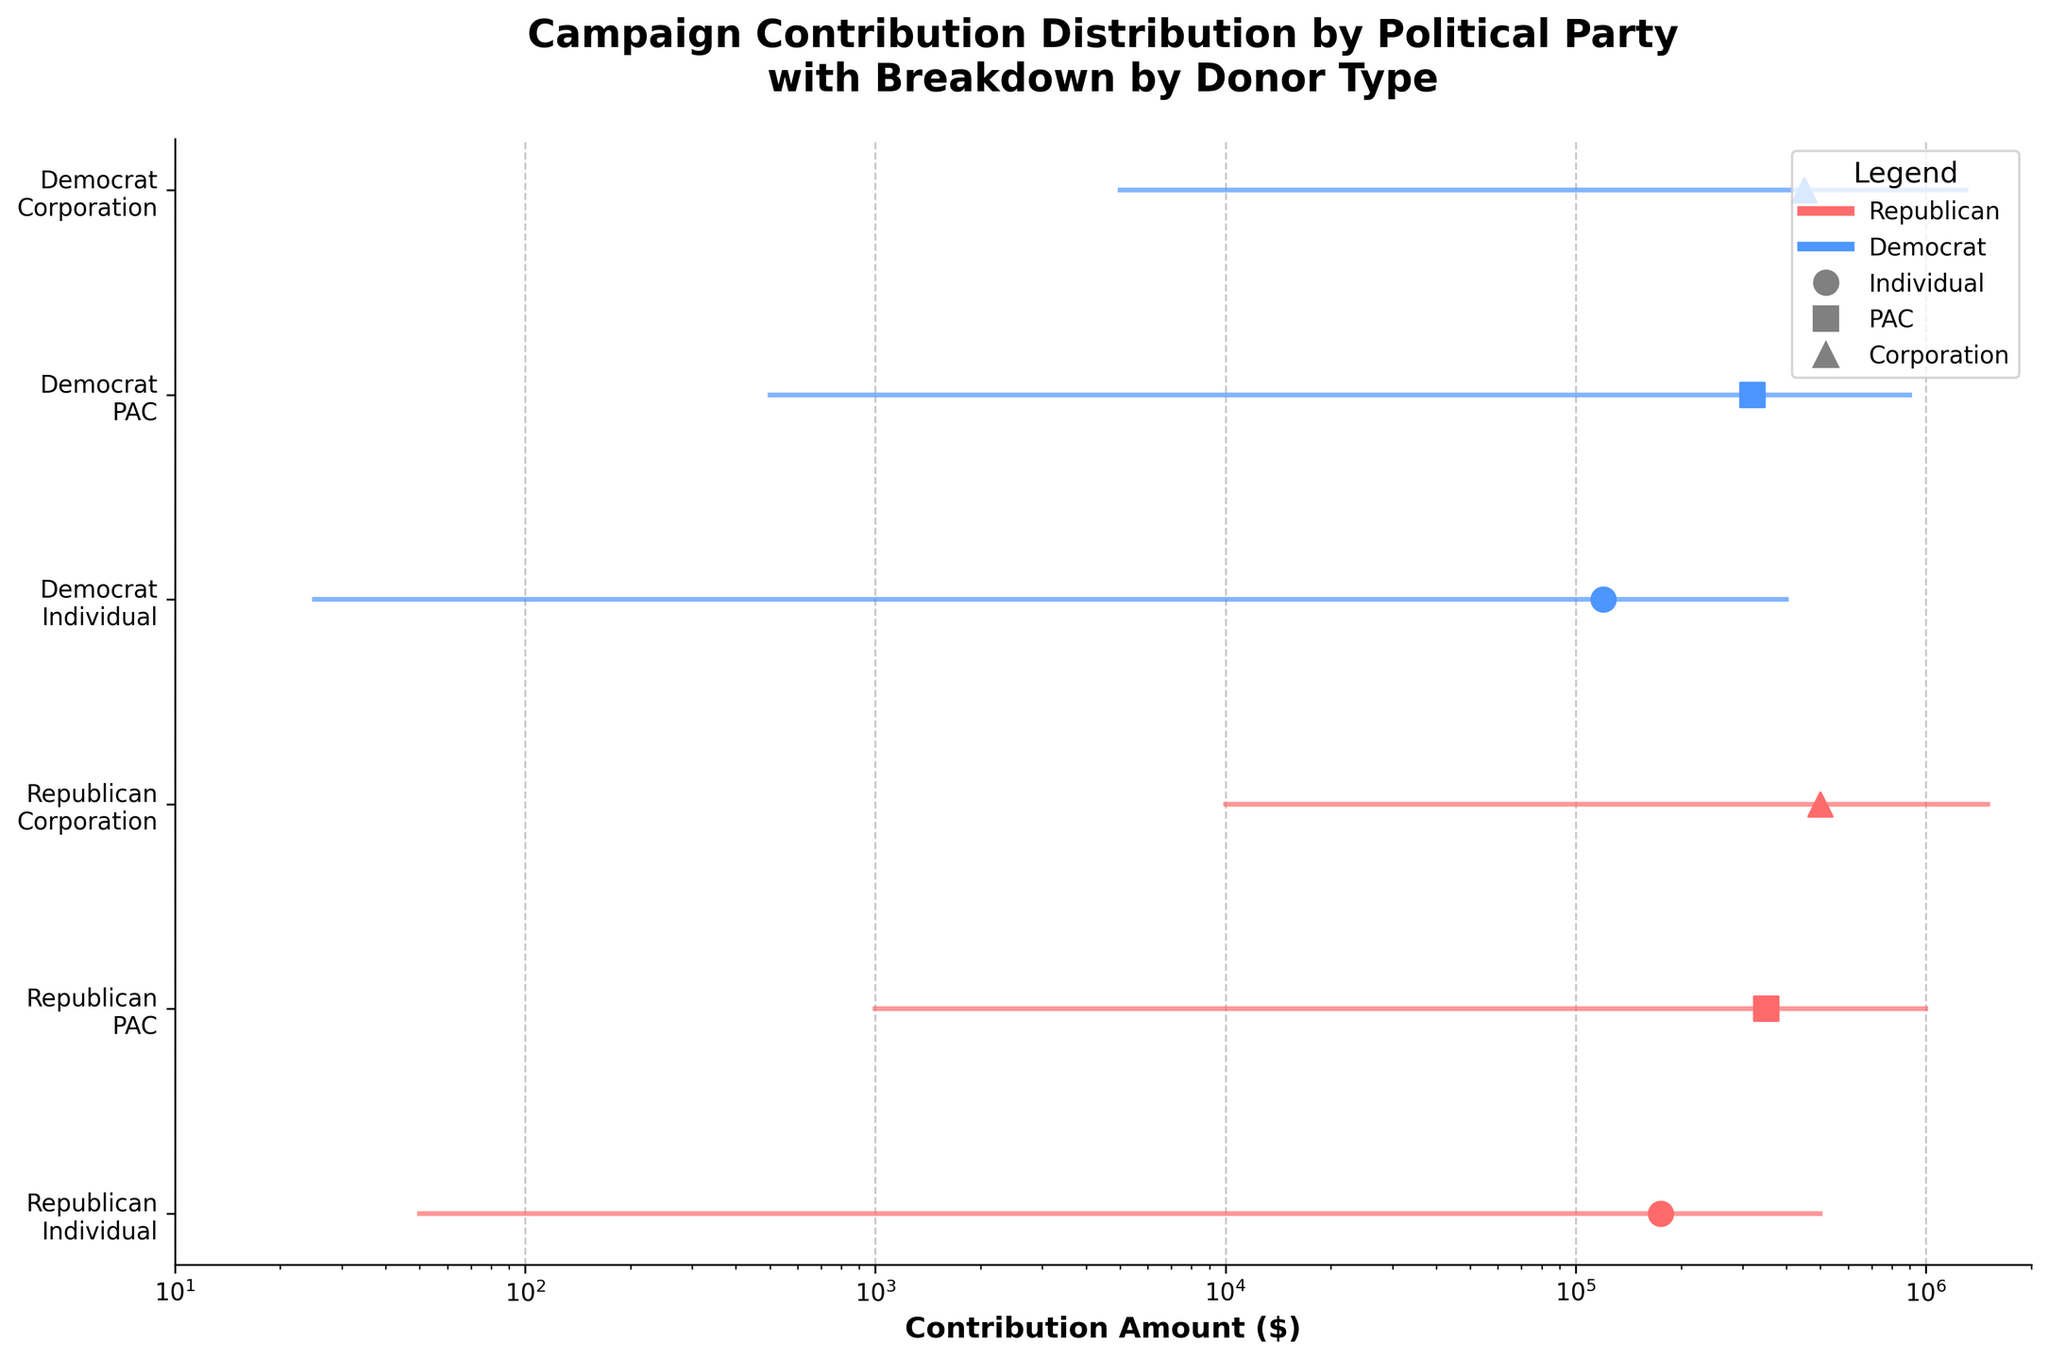What is the title of the plot? The title of the plot is generally located at the top and provides a summary of what the plot represents. In this case, the title is "Campaign Contribution Distribution by Political Party with Breakdown by Donor Type".
Answer: Campaign Contribution Distribution by Political Party with Breakdown by Donor Type What is the x-axis label in the plot? The x-axis label describes what the axis represents. Here, it is labeled "Contribution Amount ($)" indicating that this axis is showing the monetary values of contributions.
Answer: Contribution Amount ($) What is the minimum contribution from individuals to the Republican party? By looking at the starting point of the range for the "Republican\nIndividual" category on the x-axis, the lowest value indicated is the minimum contribution.
Answer: $50 Which donor type has the highest max contribution for the Democratic party? Identify the largest endpoint of the range for each donor type under the Democrat category. The Corporation for Democrats has the highest maximum contribution of $1,300,000.
Answer: Corporation Which party received the higher average contributions from PACs? Compare the position of the average contribution point (scatter symbol) for PACs between Republicans and Democrats. Republicans received higher average contributions from PACs.
Answer: Republican What's the difference between the average contributions from individuals to Republicans and Democrats? Find the average contribution points for individuals under both parties and take the difference. Republicans: $175,000; Democrats: $120,000. The difference is $175,000 - $120,000 = $55,000.
Answer: $55,000 Which donor type has the smallest range of contributions for Republicans? Calculate the range using max and min contribution values for each donor type for Republicans. The smaller range is for Individual donors: $500,000 - $50 = $499,950.
Answer: Individual Among the given donor types, which type has the largest spread in contributions for Democrats? The spread is the difference between the max and min contributions. For Democrats, the Corporation donor type has the largest spread: $1,300,000 - $5,000 = $1,295,000.
Answer: Corporation How does the max contribution from PACs compare between Republicans and Democrats? Look at the end points of the range for PAC contributors for both parties. Republicans have a higher max contribution from PACs at $1,000,000 compared to Democrats' $900,000.
Answer: Republicans have higher max contributions Identify the donor type for both parties where their average contributions lie closest to each other. Identify and compare the scatter points representing average contributions for each donor type. PAC contributions for Republicans ($350,000) and Democrats ($320,000) are closest compared to others.
Answer: PAC 